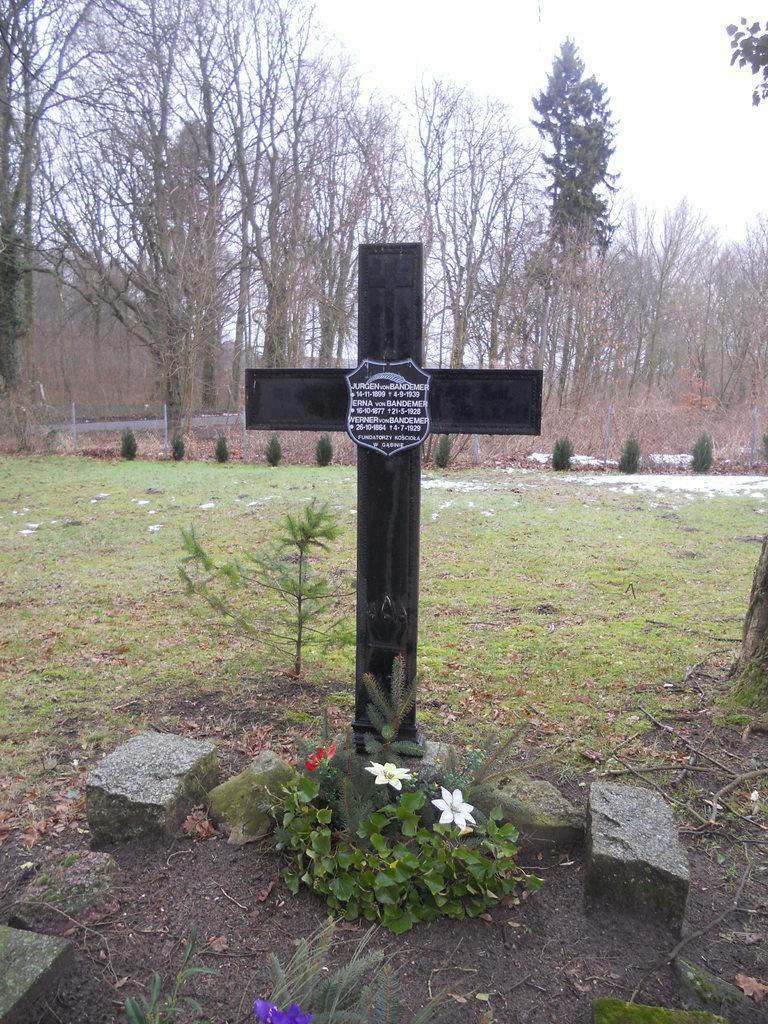How would you summarize this image in a sentence or two? In this image I can see an open grass ground and on it I can see few stones, plants and a cross. I can also see a board on the cross and on the board I can see something is written. In the background I can see few more plants, number of trees and the sky. 